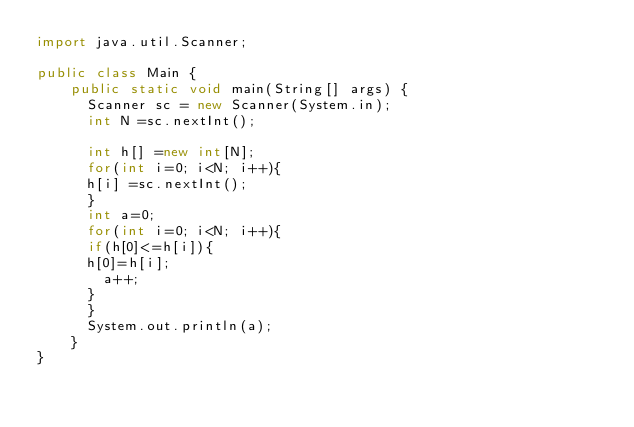Convert code to text. <code><loc_0><loc_0><loc_500><loc_500><_Java_>import java.util.Scanner;
 
public class Main {
	public static void main(String[] args) {
      Scanner sc = new Scanner(System.in);
      int N =sc.nextInt();
      
      int h[] =new int[N];
      for(int i=0; i<N; i++){
      h[i] =sc.nextInt();
      }
      int a=0;
      for(int i=0; i<N; i++){
      if(h[0]<=h[i]){
      h[0]=h[i];
        a++;
      }
      }
      System.out.println(a);
    }
}</code> 